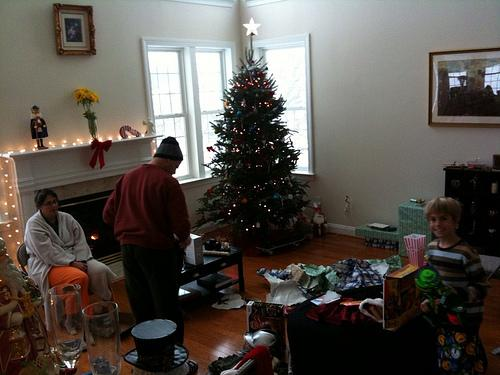Describe the attire of the woman sitting on the chair. The woman is wearing a robe, orange pants, and a white sweater. Can you name the objects that are related to Christmas placed around the room? Christmas tree, star on the tree, unopened presents, nutcracker, red bow, and discarded wrapping paper. How many glasses can be seen in the picture and where are they placed? There are two empty glasses in the corner and two glasses of champagne near the fire place. Identify the clothing of the man near the Christmas tree. A man is wearing a maroon shirt, a sweater, a cap, and black and grey ski cap. Mention the accessories on the fire place in the image. There are Christmas lights, nutcracker doll, a large red bow, and yellow flowers in a vase. Analyze the overall sentiment of the image based on its contents. The image has a celebratory and joyful sentiment, as it shows people and Christmas decorations in a warm, festive setting. Count the number of people in the image and provide a brief description of their appearance. There are four people: a smiling boy in pajamas, a seated woman in a robe, a man in a sweater and cap, and an older man in a red sweater. In this scene, what can be found on the floor in the room? There is discarded and ripped open wrapping paper on the floor. What kind of hats can be found in the image and where are they placed? There are a black top hat on the table, and a black and grey ski cap near the man in the sweater. What is the color and type of the flowers present in the vase and where is the vase located? The vase has yellow sunflowers and is located on a ledge near the fire place. What has happened to the wrapping paper on the floor? The wrapping paper is ripped open and discarded. What color is the man's shirt? The man's shirt is maroon. Describe the interaction between the boy and the toy. The boy is holding the toy and seems happy. What type of hat is on the table? A black top hat. What is on the woman's sweater? There is no specific design on the woman's sweater. Can you find three cupcakes on a plate on the fireplace mantel? There is no mention of cupcakes or a plate on the fireplace mantel in the image. Transcribe any words visible in the picture on the wall. There are no visible words on the picture in the wall. What is the color of the Christmas tree? Green. Do you see a man in a blue jacket and a cowboy hat standing next to the Christmas tree? There is a man in the image, but he is wearing a sweater and a cap, not a blue jacket and a cowboy hat, and he is not standing next to the Christmas tree. Assess the quality of the image. The image quality is good with clear objects and details. Is there a cat playing with the discarded wrapping paper on the floor? There is discarded wrapping paper on the floor in the image, but there is no cat playing with it. Is there a dog sleeping in front of the fireplace? There is no mention of a dog in the image at all, let alone one sleeping in front of the fireplace. Can you find the purple gift box with a yellow ribbon on the table? There is an unopened green present in the image, but there is no purple gift box with a yellow ribbon on the table. Separate the image into different semantic regions. People, Christmas tree, fireplace, decorations, floor (wrapping paper), and wall. Describe the emotions of the people in the image. The boy is smiling, and the other people seem to be in a pleasant mood. What's the position and size of the seated woman object? X:19 Y:188 Width:95 Height:95. Identify the objects on the fireplace. There are a nutcracker doll, a large red bow, and Christmas lights on the fireplace. Is the woman sitting or standing in this image? The woman is sitting. Describe the scene in the image. There are several people in a room with a Christmas tree, decorations, toys, gifts, and more. List any anomalies in the image. There are no major anomalies in the image. Is the woman in the blue pants and pink shirt sitting on the floor? There is a woman in the image, but she is wearing a robe and orange pants and sitting on a chair, not on the floor. Are the glasses on the floor empty or full? The glasses are empty. What type of flowers are in the vase? Yellow flowers, possibly sunflowers. Find any textual information in the image and state its location. There is no textual information in the image. How many hats are in the scene? There are three hats in the scene - a black top hat, a grey ski cap, and a hat on the man. 